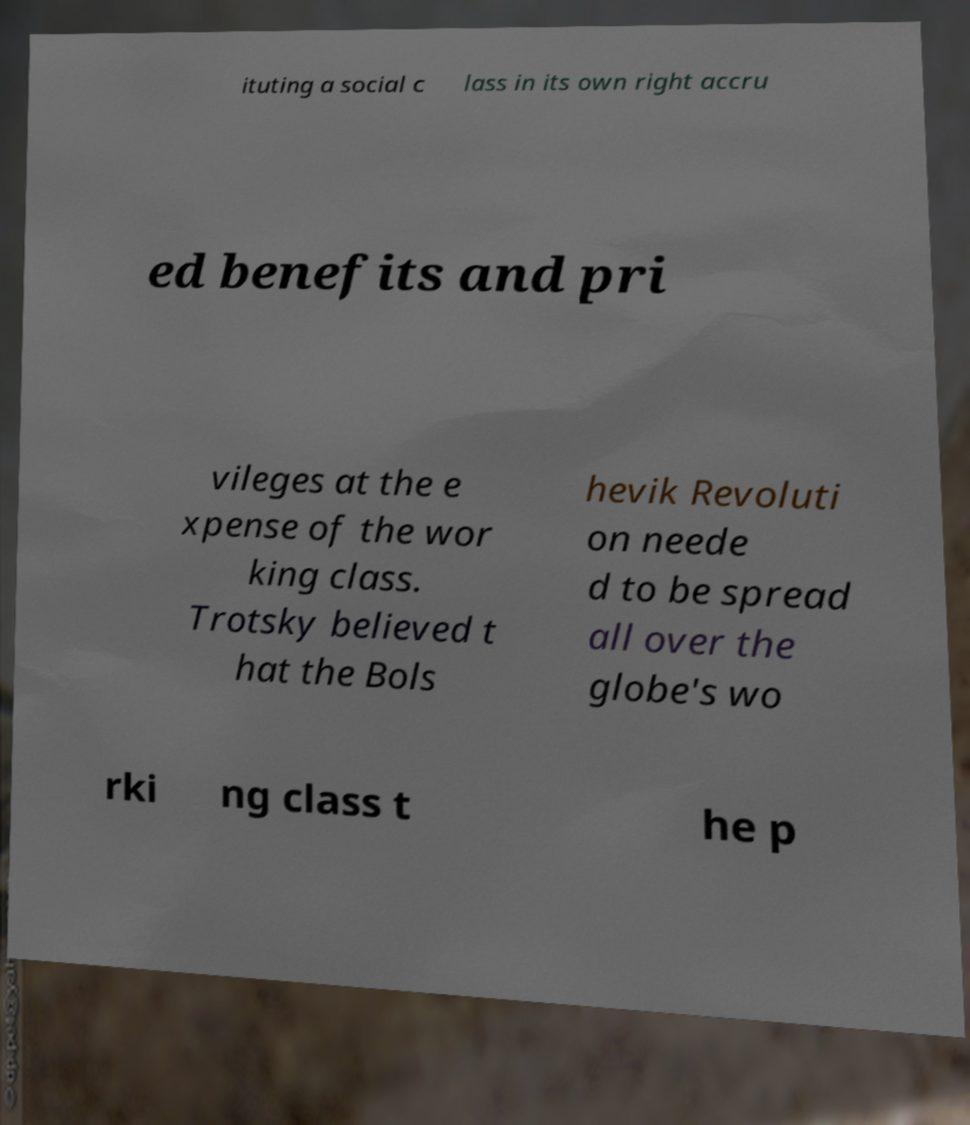There's text embedded in this image that I need extracted. Can you transcribe it verbatim? ituting a social c lass in its own right accru ed benefits and pri vileges at the e xpense of the wor king class. Trotsky believed t hat the Bols hevik Revoluti on neede d to be spread all over the globe's wo rki ng class t he p 